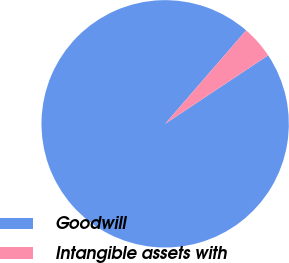Convert chart. <chart><loc_0><loc_0><loc_500><loc_500><pie_chart><fcel>Goodwill<fcel>Intangible assets with<nl><fcel>95.7%<fcel>4.3%<nl></chart> 